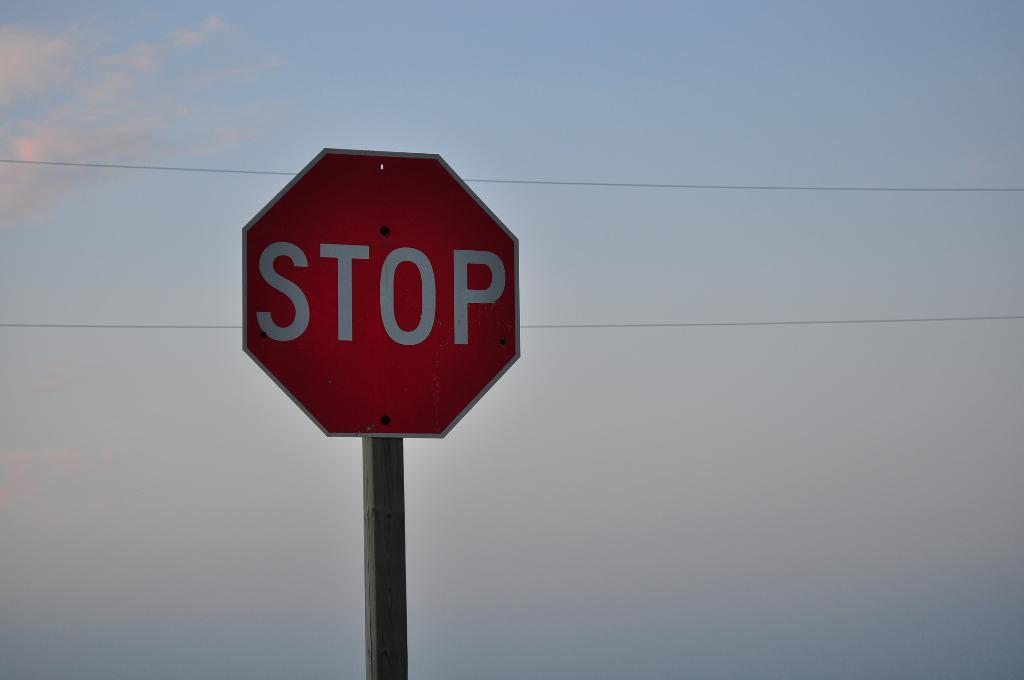<image>
Offer a succinct explanation of the picture presented. A stop sign stands against a gray barren sky and a pair of electrical wires. 